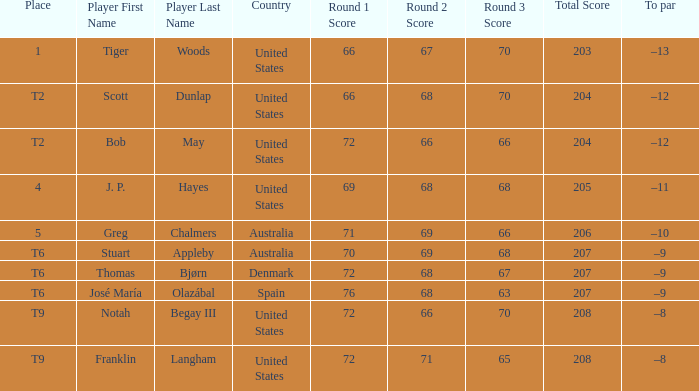Can you give me this table as a dict? {'header': ['Place', 'Player First Name', 'Player Last Name', 'Country', 'Round 1 Score', 'Round 2 Score', 'Round 3 Score', 'Total Score', 'To par'], 'rows': [['1', 'Tiger', 'Woods', 'United States', '66', '67', '70', '203', '–13'], ['T2', 'Scott', 'Dunlap', 'United States', '66', '68', '70', '204', '–12'], ['T2', 'Bob', 'May', 'United States', '72', '66', '66', '204', '–12'], ['4', 'J. P.', 'Hayes', 'United States', '69', '68', '68', '205', '–11'], ['5', 'Greg', 'Chalmers', 'Australia', '71', '69', '66', '206', '–10'], ['T6', 'Stuart', 'Appleby', 'Australia', '70', '69', '68', '207', '–9'], ['T6', 'Thomas', 'Bjørn', 'Denmark', '72', '68', '67', '207', '–9'], ['T6', 'José María', 'Olazábal', 'Spain', '76', '68', '63', '207', '–9'], ['T9', 'Notah', 'Begay III', 'United States', '72', '66', '70', '208', '–8'], ['T9', 'Franklin', 'Langham', 'United States', '72', '71', '65', '208', '–8']]} What is the position of the player with a 66-68-70=204 score? T2. 